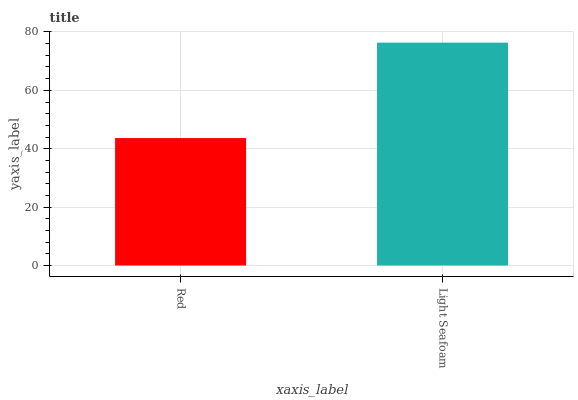Is Light Seafoam the minimum?
Answer yes or no. No. Is Light Seafoam greater than Red?
Answer yes or no. Yes. Is Red less than Light Seafoam?
Answer yes or no. Yes. Is Red greater than Light Seafoam?
Answer yes or no. No. Is Light Seafoam less than Red?
Answer yes or no. No. Is Light Seafoam the high median?
Answer yes or no. Yes. Is Red the low median?
Answer yes or no. Yes. Is Red the high median?
Answer yes or no. No. Is Light Seafoam the low median?
Answer yes or no. No. 